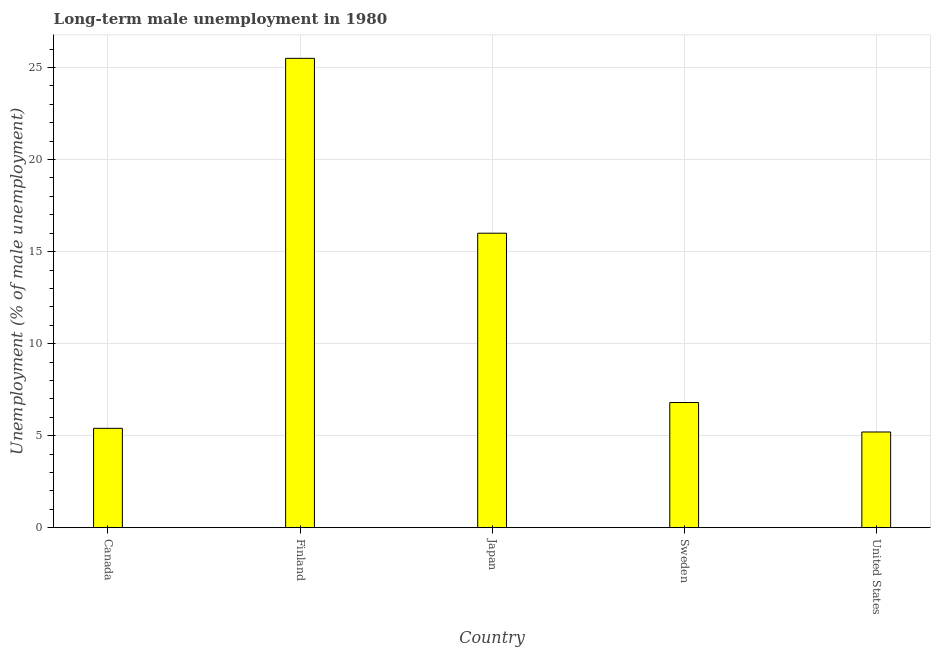Does the graph contain any zero values?
Provide a short and direct response. No. Does the graph contain grids?
Give a very brief answer. Yes. What is the title of the graph?
Your answer should be compact. Long-term male unemployment in 1980. What is the label or title of the X-axis?
Provide a succinct answer. Country. What is the label or title of the Y-axis?
Your answer should be compact. Unemployment (% of male unemployment). What is the long-term male unemployment in Sweden?
Offer a terse response. 6.8. Across all countries, what is the maximum long-term male unemployment?
Provide a short and direct response. 25.5. Across all countries, what is the minimum long-term male unemployment?
Keep it short and to the point. 5.2. In which country was the long-term male unemployment maximum?
Keep it short and to the point. Finland. In which country was the long-term male unemployment minimum?
Your answer should be very brief. United States. What is the sum of the long-term male unemployment?
Make the answer very short. 58.9. What is the average long-term male unemployment per country?
Give a very brief answer. 11.78. What is the median long-term male unemployment?
Your answer should be compact. 6.8. What is the ratio of the long-term male unemployment in Canada to that in Japan?
Ensure brevity in your answer.  0.34. What is the difference between the highest and the lowest long-term male unemployment?
Offer a very short reply. 20.3. What is the Unemployment (% of male unemployment) of Canada?
Ensure brevity in your answer.  5.4. What is the Unemployment (% of male unemployment) of Finland?
Keep it short and to the point. 25.5. What is the Unemployment (% of male unemployment) in Japan?
Your response must be concise. 16. What is the Unemployment (% of male unemployment) in Sweden?
Keep it short and to the point. 6.8. What is the Unemployment (% of male unemployment) of United States?
Your response must be concise. 5.2. What is the difference between the Unemployment (% of male unemployment) in Canada and Finland?
Provide a short and direct response. -20.1. What is the difference between the Unemployment (% of male unemployment) in Canada and Sweden?
Provide a succinct answer. -1.4. What is the difference between the Unemployment (% of male unemployment) in Canada and United States?
Give a very brief answer. 0.2. What is the difference between the Unemployment (% of male unemployment) in Finland and Japan?
Offer a terse response. 9.5. What is the difference between the Unemployment (% of male unemployment) in Finland and Sweden?
Offer a terse response. 18.7. What is the difference between the Unemployment (% of male unemployment) in Finland and United States?
Provide a succinct answer. 20.3. What is the difference between the Unemployment (% of male unemployment) in Japan and Sweden?
Keep it short and to the point. 9.2. What is the difference between the Unemployment (% of male unemployment) in Japan and United States?
Keep it short and to the point. 10.8. What is the ratio of the Unemployment (% of male unemployment) in Canada to that in Finland?
Your answer should be compact. 0.21. What is the ratio of the Unemployment (% of male unemployment) in Canada to that in Japan?
Ensure brevity in your answer.  0.34. What is the ratio of the Unemployment (% of male unemployment) in Canada to that in Sweden?
Ensure brevity in your answer.  0.79. What is the ratio of the Unemployment (% of male unemployment) in Canada to that in United States?
Ensure brevity in your answer.  1.04. What is the ratio of the Unemployment (% of male unemployment) in Finland to that in Japan?
Provide a succinct answer. 1.59. What is the ratio of the Unemployment (% of male unemployment) in Finland to that in Sweden?
Keep it short and to the point. 3.75. What is the ratio of the Unemployment (% of male unemployment) in Finland to that in United States?
Offer a very short reply. 4.9. What is the ratio of the Unemployment (% of male unemployment) in Japan to that in Sweden?
Your answer should be very brief. 2.35. What is the ratio of the Unemployment (% of male unemployment) in Japan to that in United States?
Provide a short and direct response. 3.08. What is the ratio of the Unemployment (% of male unemployment) in Sweden to that in United States?
Your answer should be very brief. 1.31. 